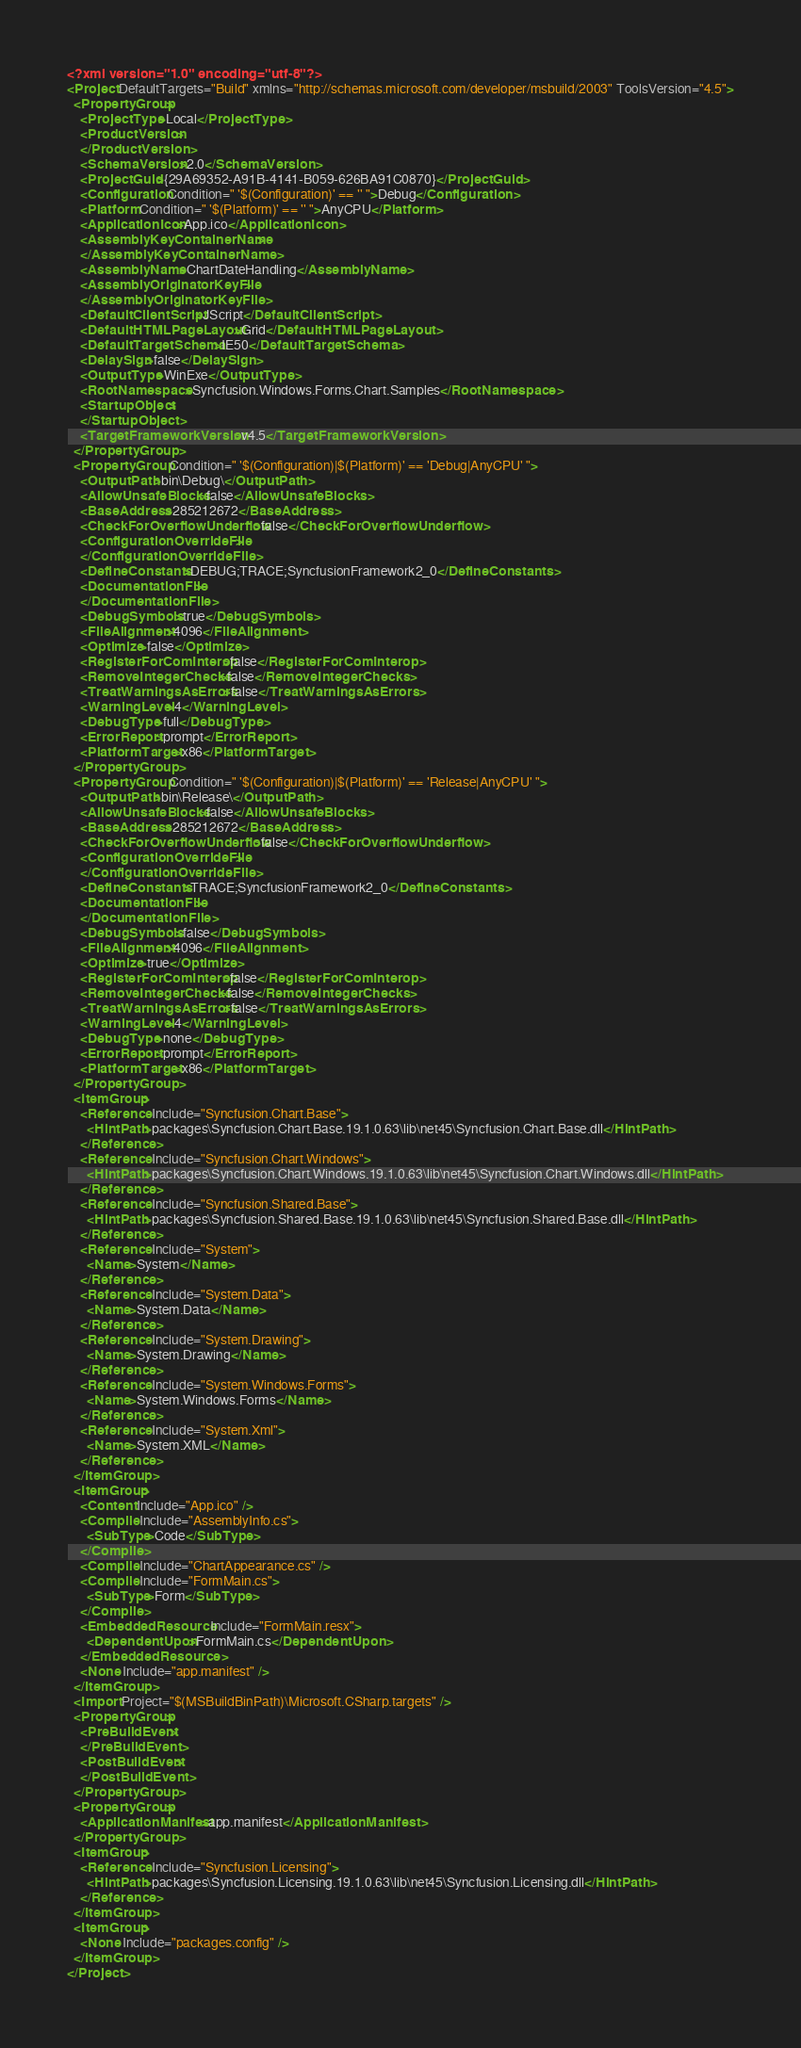Convert code to text. <code><loc_0><loc_0><loc_500><loc_500><_XML_><?xml version="1.0" encoding="utf-8"?>
<Project DefaultTargets="Build" xmlns="http://schemas.microsoft.com/developer/msbuild/2003" ToolsVersion="4.5">
  <PropertyGroup>
    <ProjectType>Local</ProjectType>
    <ProductVersion>
    </ProductVersion>
    <SchemaVersion>2.0</SchemaVersion>
    <ProjectGuid>{29A69352-A91B-4141-B059-626BA91C0870}</ProjectGuid>
    <Configuration Condition=" '$(Configuration)' == '' ">Debug</Configuration>
    <Platform Condition=" '$(Platform)' == '' ">AnyCPU</Platform>
    <ApplicationIcon>App.ico</ApplicationIcon>
    <AssemblyKeyContainerName>
    </AssemblyKeyContainerName>
    <AssemblyName>ChartDateHandling</AssemblyName>
    <AssemblyOriginatorKeyFile>
    </AssemblyOriginatorKeyFile>
    <DefaultClientScript>JScript</DefaultClientScript>
    <DefaultHTMLPageLayout>Grid</DefaultHTMLPageLayout>
    <DefaultTargetSchema>IE50</DefaultTargetSchema>
    <DelaySign>false</DelaySign>
    <OutputType>WinExe</OutputType>
    <RootNamespace>Syncfusion.Windows.Forms.Chart.Samples</RootNamespace>
    <StartupObject>
    </StartupObject>
    <TargetFrameworkVersion>v4.5</TargetFrameworkVersion>
  </PropertyGroup>
  <PropertyGroup Condition=" '$(Configuration)|$(Platform)' == 'Debug|AnyCPU' ">
    <OutputPath>bin\Debug\</OutputPath>
    <AllowUnsafeBlocks>false</AllowUnsafeBlocks>
    <BaseAddress>285212672</BaseAddress>
    <CheckForOverflowUnderflow>false</CheckForOverflowUnderflow>
    <ConfigurationOverrideFile>
    </ConfigurationOverrideFile>
    <DefineConstants>DEBUG;TRACE;SyncfusionFramework2_0</DefineConstants>
    <DocumentationFile>
    </DocumentationFile>
    <DebugSymbols>true</DebugSymbols>
    <FileAlignment>4096</FileAlignment>
    <Optimize>false</Optimize>
    <RegisterForComInterop>false</RegisterForComInterop>
    <RemoveIntegerChecks>false</RemoveIntegerChecks>
    <TreatWarningsAsErrors>false</TreatWarningsAsErrors>
    <WarningLevel>4</WarningLevel>
    <DebugType>full</DebugType>
    <ErrorReport>prompt</ErrorReport>
    <PlatformTarget>x86</PlatformTarget>
  </PropertyGroup>
  <PropertyGroup Condition=" '$(Configuration)|$(Platform)' == 'Release|AnyCPU' ">
    <OutputPath>bin\Release\</OutputPath>
    <AllowUnsafeBlocks>false</AllowUnsafeBlocks>
    <BaseAddress>285212672</BaseAddress>
    <CheckForOverflowUnderflow>false</CheckForOverflowUnderflow>
    <ConfigurationOverrideFile>
    </ConfigurationOverrideFile>
    <DefineConstants>TRACE;SyncfusionFramework2_0</DefineConstants>
    <DocumentationFile>
    </DocumentationFile>
    <DebugSymbols>false</DebugSymbols>
    <FileAlignment>4096</FileAlignment>
    <Optimize>true</Optimize>
    <RegisterForComInterop>false</RegisterForComInterop>
    <RemoveIntegerChecks>false</RemoveIntegerChecks>
    <TreatWarningsAsErrors>false</TreatWarningsAsErrors>
    <WarningLevel>4</WarningLevel>
    <DebugType>none</DebugType>
    <ErrorReport>prompt</ErrorReport>
    <PlatformTarget>x86</PlatformTarget>
  </PropertyGroup>
  <ItemGroup>
    <Reference Include="Syncfusion.Chart.Base">
      <HintPath>packages\Syncfusion.Chart.Base.19.1.0.63\lib\net45\Syncfusion.Chart.Base.dll</HintPath>
    </Reference>
    <Reference Include="Syncfusion.Chart.Windows">
      <HintPath>packages\Syncfusion.Chart.Windows.19.1.0.63\lib\net45\Syncfusion.Chart.Windows.dll</HintPath>
    </Reference>
    <Reference Include="Syncfusion.Shared.Base">
      <HintPath>packages\Syncfusion.Shared.Base.19.1.0.63\lib\net45\Syncfusion.Shared.Base.dll</HintPath>
    </Reference>
    <Reference Include="System">
      <Name>System</Name>
    </Reference>
    <Reference Include="System.Data">
      <Name>System.Data</Name>
    </Reference>
    <Reference Include="System.Drawing">
      <Name>System.Drawing</Name>
    </Reference>
    <Reference Include="System.Windows.Forms">
      <Name>System.Windows.Forms</Name>
    </Reference>
    <Reference Include="System.Xml">
      <Name>System.XML</Name>
    </Reference>
  </ItemGroup>
  <ItemGroup>
    <Content Include="App.ico" />
    <Compile Include="AssemblyInfo.cs">
      <SubType>Code</SubType>
    </Compile>
    <Compile Include="ChartAppearance.cs" />
    <Compile Include="FormMain.cs">
      <SubType>Form</SubType>
    </Compile>
    <EmbeddedResource Include="FormMain.resx">
      <DependentUpon>FormMain.cs</DependentUpon>
    </EmbeddedResource>
    <None Include="app.manifest" />
  </ItemGroup>
  <Import Project="$(MSBuildBinPath)\Microsoft.CSharp.targets" />
  <PropertyGroup>
    <PreBuildEvent>
    </PreBuildEvent>
    <PostBuildEvent>
    </PostBuildEvent>
  </PropertyGroup>
  <PropertyGroup>
    <ApplicationManifest>app.manifest</ApplicationManifest>
  </PropertyGroup>
  <ItemGroup>
    <Reference Include="Syncfusion.Licensing">
      <HintPath>packages\Syncfusion.Licensing.19.1.0.63\lib\net45\Syncfusion.Licensing.dll</HintPath>
    </Reference>
  </ItemGroup>
  <ItemGroup>
    <None Include="packages.config" />
  </ItemGroup>
</Project></code> 